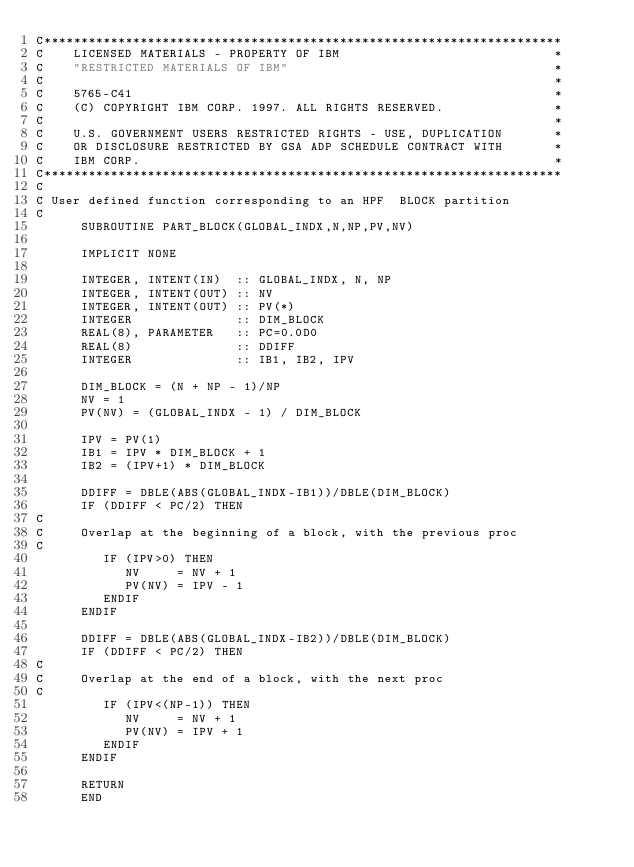Convert code to text. <code><loc_0><loc_0><loc_500><loc_500><_FORTRAN_>C**********************************************************************
C    LICENSED MATERIALS - PROPERTY OF IBM                             *
C    "RESTRICTED MATERIALS OF IBM"                                    *
C                                                                     *
C    5765-C41                                                         *
C    (C) COPYRIGHT IBM CORP. 1997. ALL RIGHTS RESERVED.               *
C                                                                     *
C    U.S. GOVERNMENT USERS RESTRICTED RIGHTS - USE, DUPLICATION       *
C    OR DISCLOSURE RESTRICTED BY GSA ADP SCHEDULE CONTRACT WITH       *
C    IBM CORP.                                                        *
C**********************************************************************
C
C User defined function corresponding to an HPF  BLOCK partition 
C
      SUBROUTINE PART_BLOCK(GLOBAL_INDX,N,NP,PV,NV)
      
      IMPLICIT NONE
      
      INTEGER, INTENT(IN)  :: GLOBAL_INDX, N, NP
      INTEGER, INTENT(OUT) :: NV
      INTEGER, INTENT(OUT) :: PV(*)
      INTEGER              :: DIM_BLOCK
      REAL(8), PARAMETER   :: PC=0.0D0
      REAL(8)              :: DDIFF
      INTEGER              :: IB1, IB2, IPV
      
      DIM_BLOCK = (N + NP - 1)/NP
      NV = 1  
      PV(NV) = (GLOBAL_INDX - 1) / DIM_BLOCK
      
      IPV = PV(1)
      IB1 = IPV * DIM_BLOCK + 1
      IB2 = (IPV+1) * DIM_BLOCK
      
      DDIFF = DBLE(ABS(GLOBAL_INDX-IB1))/DBLE(DIM_BLOCK)
      IF (DDIFF < PC/2) THEN
C
C     Overlap at the beginning of a block, with the previous proc
C         
         IF (IPV>0) THEN 
            NV     = NV + 1
            PV(NV) = IPV - 1
         ENDIF
      ENDIF

      DDIFF = DBLE(ABS(GLOBAL_INDX-IB2))/DBLE(DIM_BLOCK)
      IF (DDIFF < PC/2) THEN
C
C     Overlap at the end of a block, with the next proc
C         
         IF (IPV<(NP-1)) THEN 
            NV     = NV + 1
            PV(NV) = IPV + 1
         ENDIF
      ENDIF
      
      RETURN
      END 
      
</code> 